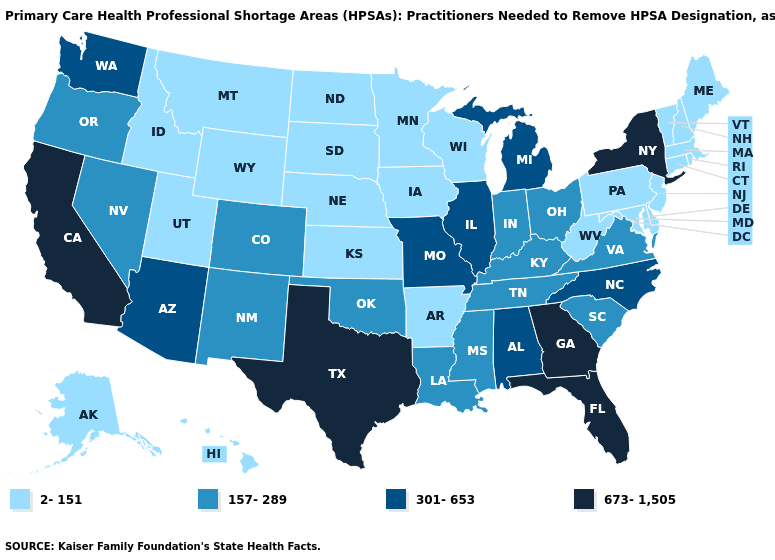Which states have the highest value in the USA?
Quick response, please. California, Florida, Georgia, New York, Texas. What is the value of California?
Give a very brief answer. 673-1,505. What is the value of Illinois?
Answer briefly. 301-653. Name the states that have a value in the range 2-151?
Write a very short answer. Alaska, Arkansas, Connecticut, Delaware, Hawaii, Idaho, Iowa, Kansas, Maine, Maryland, Massachusetts, Minnesota, Montana, Nebraska, New Hampshire, New Jersey, North Dakota, Pennsylvania, Rhode Island, South Dakota, Utah, Vermont, West Virginia, Wisconsin, Wyoming. Does New Hampshire have the lowest value in the Northeast?
Answer briefly. Yes. What is the lowest value in the USA?
Short answer required. 2-151. What is the highest value in states that border Idaho?
Short answer required. 301-653. Among the states that border Oklahoma , does Arkansas have the highest value?
Quick response, please. No. Does the map have missing data?
Write a very short answer. No. Does California have a lower value than Rhode Island?
Write a very short answer. No. Does California have the highest value in the West?
Concise answer only. Yes. What is the value of Virginia?
Quick response, please. 157-289. Is the legend a continuous bar?
Keep it brief. No. Which states have the highest value in the USA?
Be succinct. California, Florida, Georgia, New York, Texas. Does Massachusetts have a lower value than New Jersey?
Keep it brief. No. 